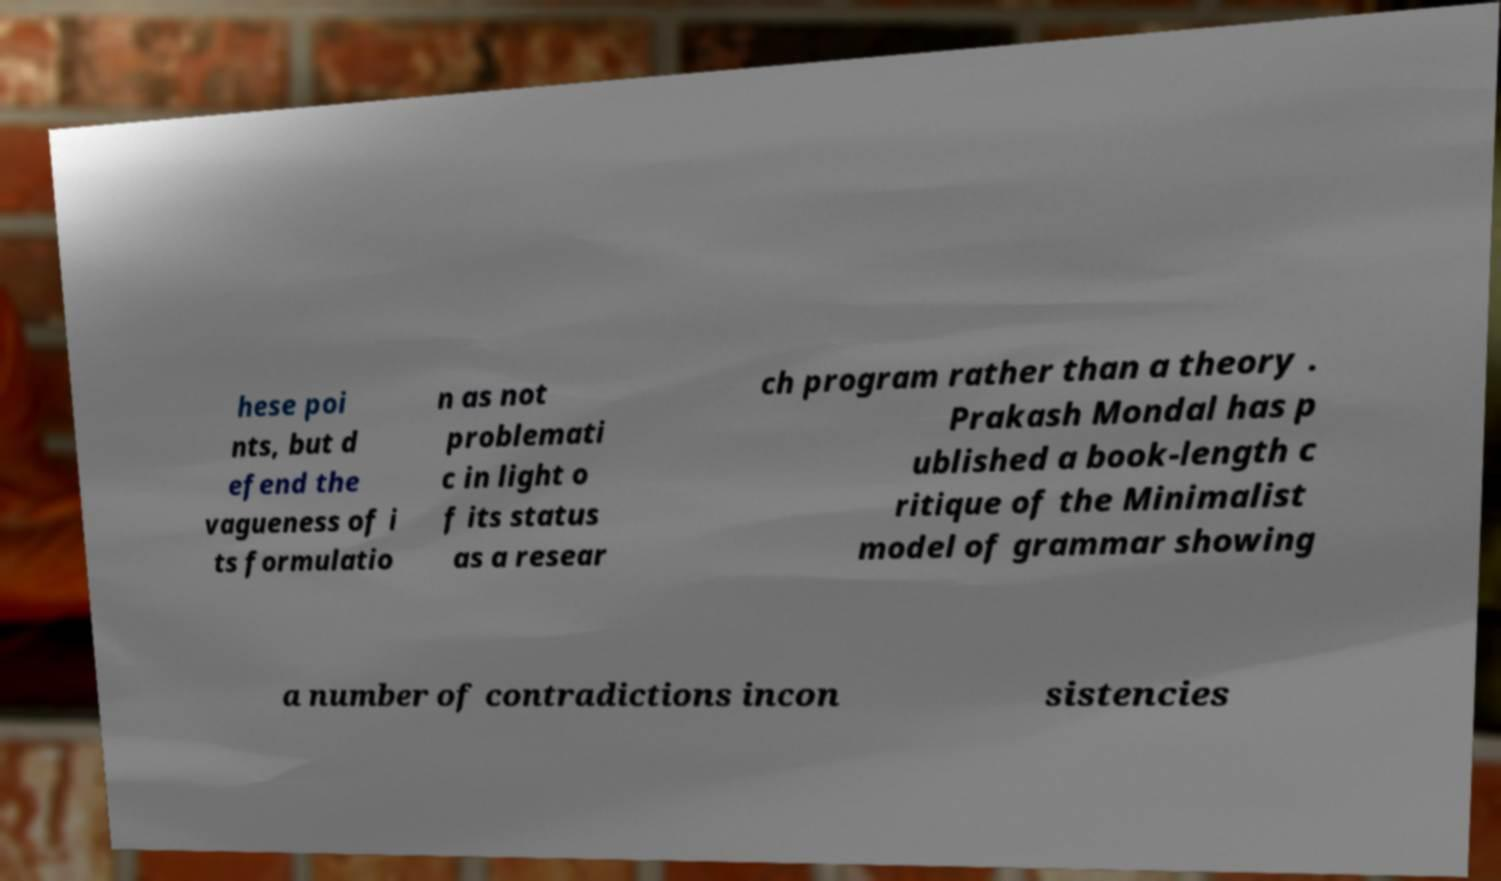For documentation purposes, I need the text within this image transcribed. Could you provide that? hese poi nts, but d efend the vagueness of i ts formulatio n as not problemati c in light o f its status as a resear ch program rather than a theory . Prakash Mondal has p ublished a book-length c ritique of the Minimalist model of grammar showing a number of contradictions incon sistencies 